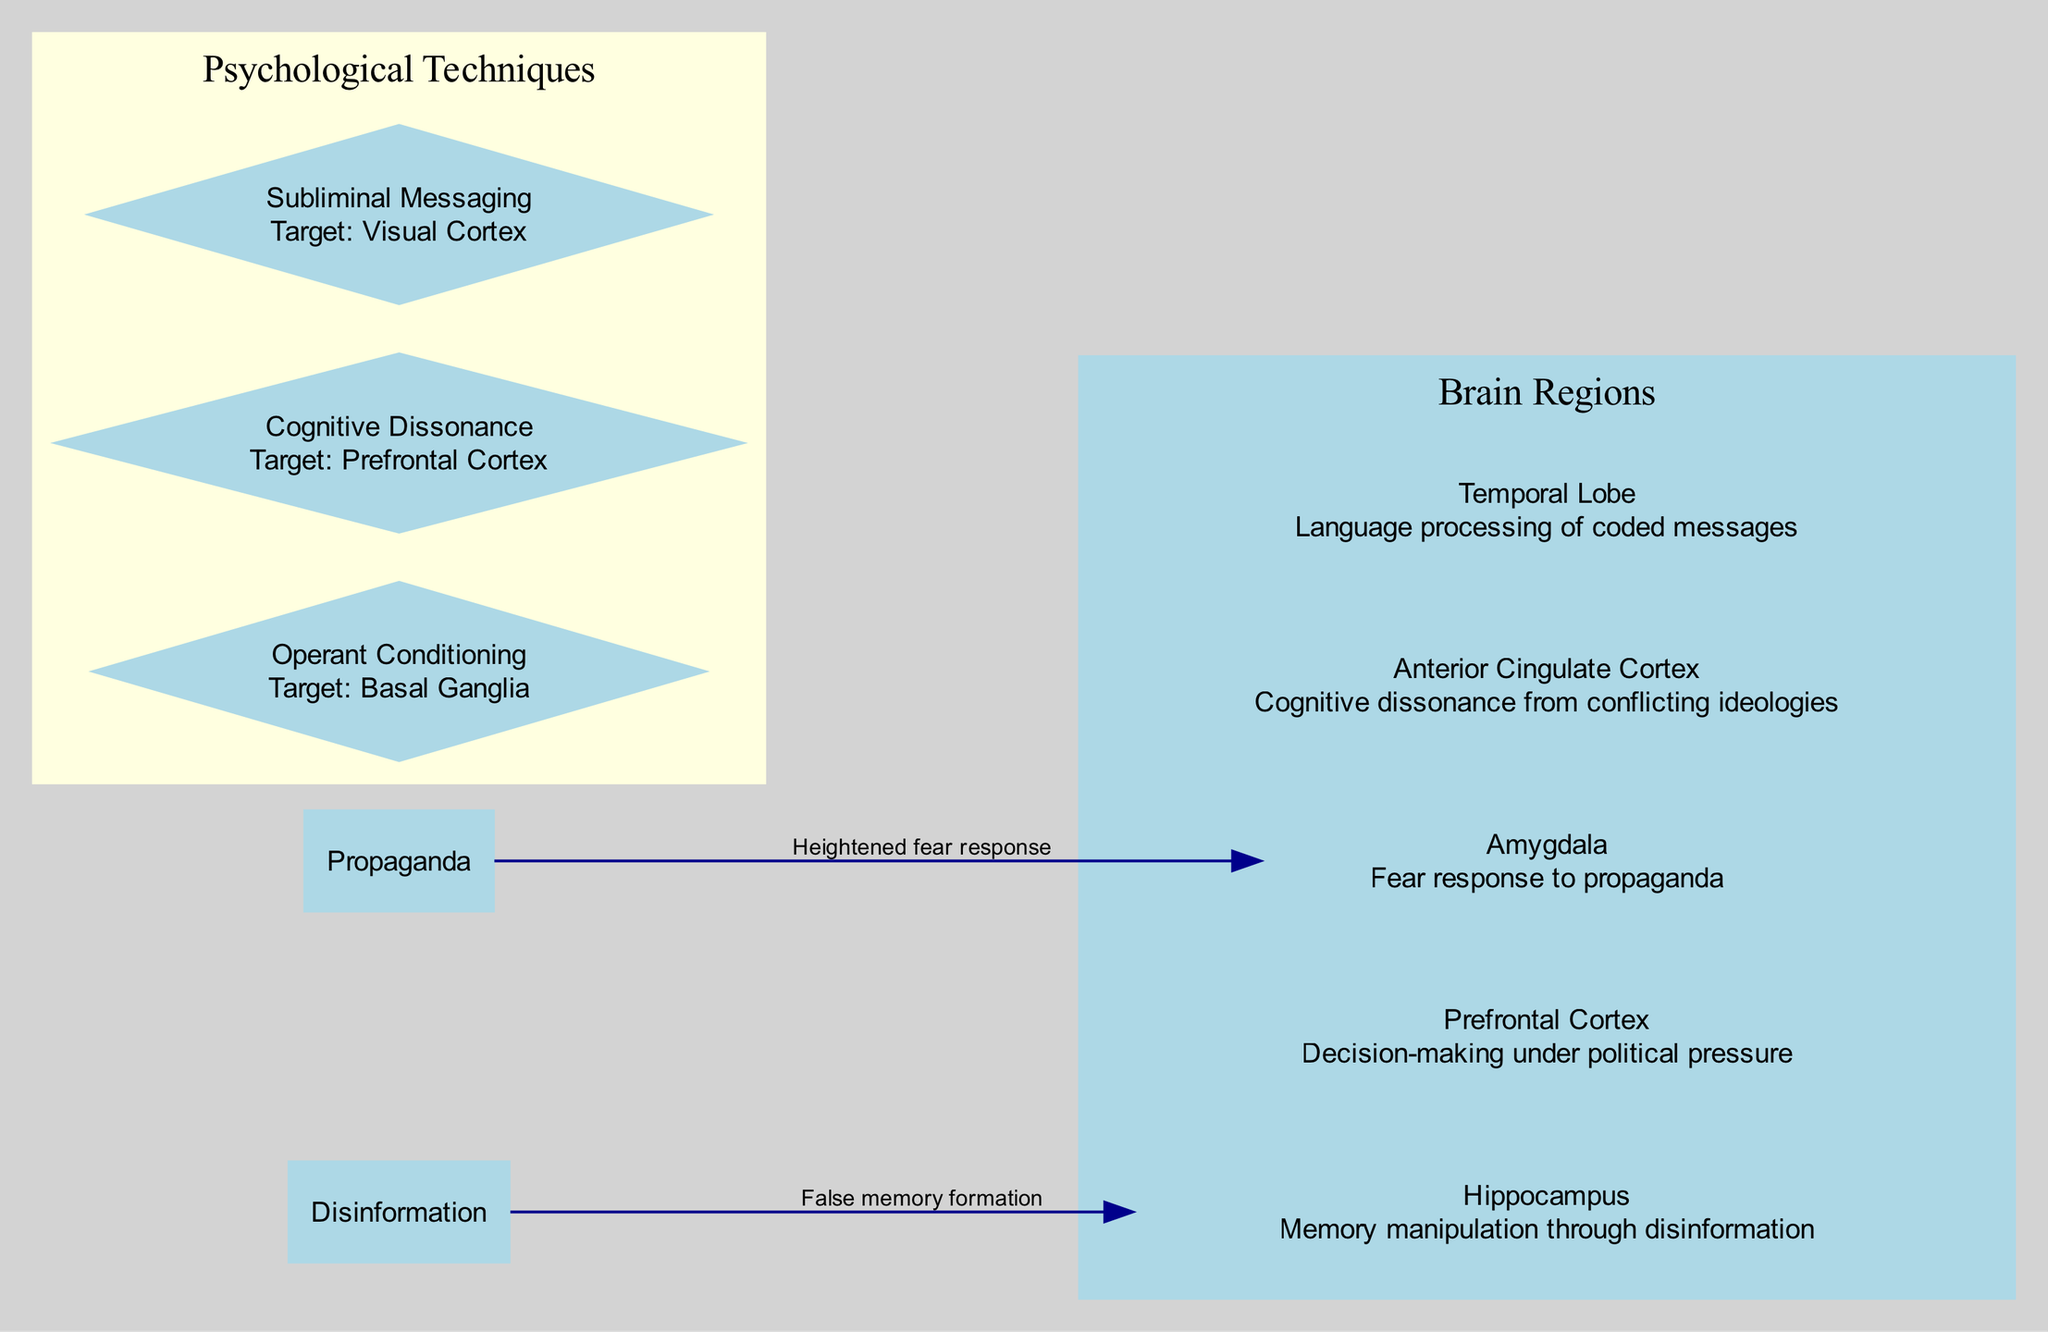What area is associated with fear response to propaganda? The diagram indicates that the Amygdala is linked to the fear response, explicitly noting its role in reacting to propaganda.
Answer: Amygdala Which brain region deals with decision-making under political pressure? Observing the diagram, the Prefrontal Cortex is identified as the area responsible for decision-making in contexts of political pressure.
Answer: Prefrontal Cortex How many psychological techniques are indicated in the diagram? The diagram lists three psychological techniques: Operant Conditioning, Cognitive Dissonance, and Subliminal Messaging, leading to a total of three techniques.
Answer: 3 What effect does disinformation have on the hippocampus? According to the diagram, disinformation leads to false memory formation, which is the specific effect noted for the hippocampus.
Answer: False memory formation Which psychological technique targets the Prefrontal Cortex? The diagram shows that Cognitive Dissonance is the psychological technique specifically targeting the Prefrontal Cortex.
Answer: Cognitive Dissonance What link is shown between propaganda and the amygdala? The diagram illustrates a direct connection from Propaganda to the Amygdala, with the effect being a heightened fear response.
Answer: Heightened fear response What is the target of subliminal messaging? The diagram indicates that Subliminal Messaging is targeted at the Visual Cortex, denoting its specific focal point within the brain's processing areas.
Answer: Visual Cortex Which brain region is affected by cognitive dissonance? From the diagram, it is clear that the Prefrontal Cortex is the brain region impacted by cognitive dissonance.
Answer: Prefrontal Cortex What is the connection between disinformation and its effect on memory? The diagram explicitly states that disinformation leads to false memory formation, linking it clearly to its influence on the memory system.
Answer: False memory formation 